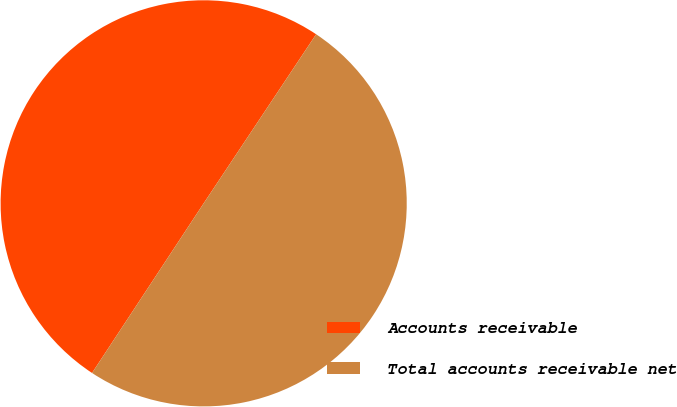Convert chart. <chart><loc_0><loc_0><loc_500><loc_500><pie_chart><fcel>Accounts receivable<fcel>Total accounts receivable net<nl><fcel>50.08%<fcel>49.92%<nl></chart> 